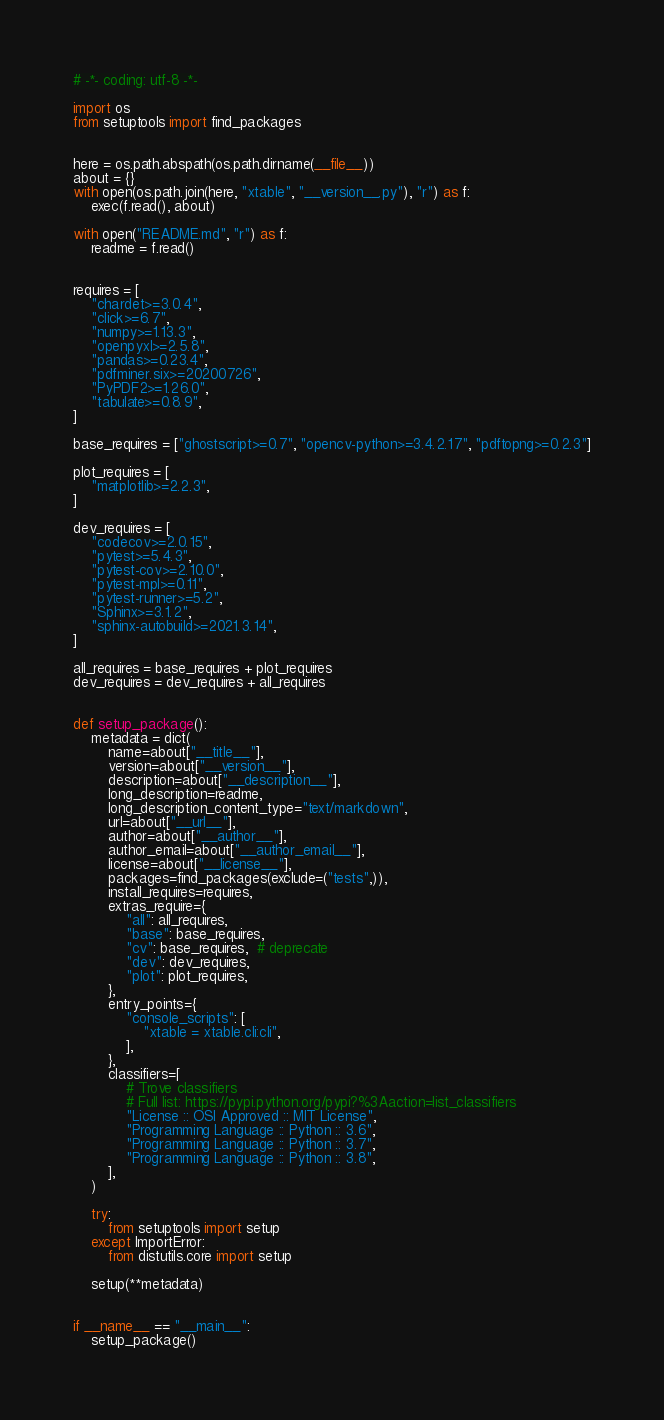<code> <loc_0><loc_0><loc_500><loc_500><_Python_># -*- coding: utf-8 -*-

import os
from setuptools import find_packages


here = os.path.abspath(os.path.dirname(__file__))
about = {}
with open(os.path.join(here, "xtable", "__version__.py"), "r") as f:
    exec(f.read(), about)

with open("README.md", "r") as f:
    readme = f.read()


requires = [
    "chardet>=3.0.4",
    "click>=6.7",
    "numpy>=1.13.3",
    "openpyxl>=2.5.8",
    "pandas>=0.23.4",
    "pdfminer.six>=20200726",
    "PyPDF2>=1.26.0",
    "tabulate>=0.8.9",
]

base_requires = ["ghostscript>=0.7", "opencv-python>=3.4.2.17", "pdftopng>=0.2.3"]

plot_requires = [
    "matplotlib>=2.2.3",
]

dev_requires = [
    "codecov>=2.0.15",
    "pytest>=5.4.3",
    "pytest-cov>=2.10.0",
    "pytest-mpl>=0.11",
    "pytest-runner>=5.2",
    "Sphinx>=3.1.2",
    "sphinx-autobuild>=2021.3.14",
]

all_requires = base_requires + plot_requires
dev_requires = dev_requires + all_requires


def setup_package():
    metadata = dict(
        name=about["__title__"],
        version=about["__version__"],
        description=about["__description__"],
        long_description=readme,
        long_description_content_type="text/markdown",
        url=about["__url__"],
        author=about["__author__"],
        author_email=about["__author_email__"],
        license=about["__license__"],
        packages=find_packages(exclude=("tests",)),
        install_requires=requires,
        extras_require={
            "all": all_requires,
            "base": base_requires,
            "cv": base_requires,  # deprecate
            "dev": dev_requires,
            "plot": plot_requires,
        },
        entry_points={
            "console_scripts": [
                "xtable = xtable.cli:cli",
            ],
        },
        classifiers=[
            # Trove classifiers
            # Full list: https://pypi.python.org/pypi?%3Aaction=list_classifiers
            "License :: OSI Approved :: MIT License",
            "Programming Language :: Python :: 3.6",
            "Programming Language :: Python :: 3.7",
            "Programming Language :: Python :: 3.8",
        ],
    )

    try:
        from setuptools import setup
    except ImportError:
        from distutils.core import setup

    setup(**metadata)


if __name__ == "__main__":
    setup_package()
</code> 